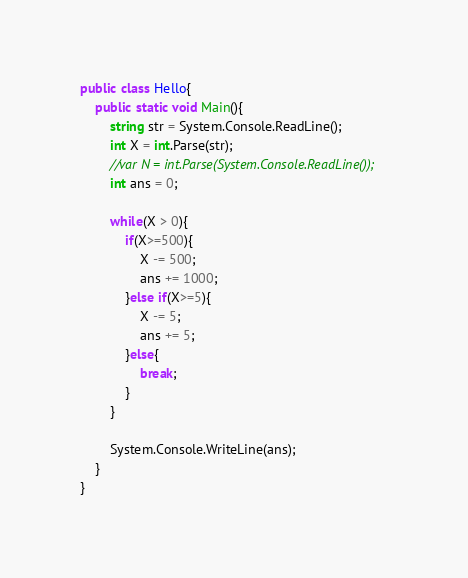<code> <loc_0><loc_0><loc_500><loc_500><_C#_>public class Hello{
    public static void Main(){
        string str = System.Console.ReadLine();
        int X = int.Parse(str);
        //var N = int.Parse(System.Console.ReadLine());
        int ans = 0;
        
        while(X > 0){
            if(X>=500){
                X -= 500;
                ans += 1000;
            }else if(X>=5){
                X -= 5;
                ans += 5;
            }else{
                break;
            }
        }
        
        System.Console.WriteLine(ans);
    }
}</code> 